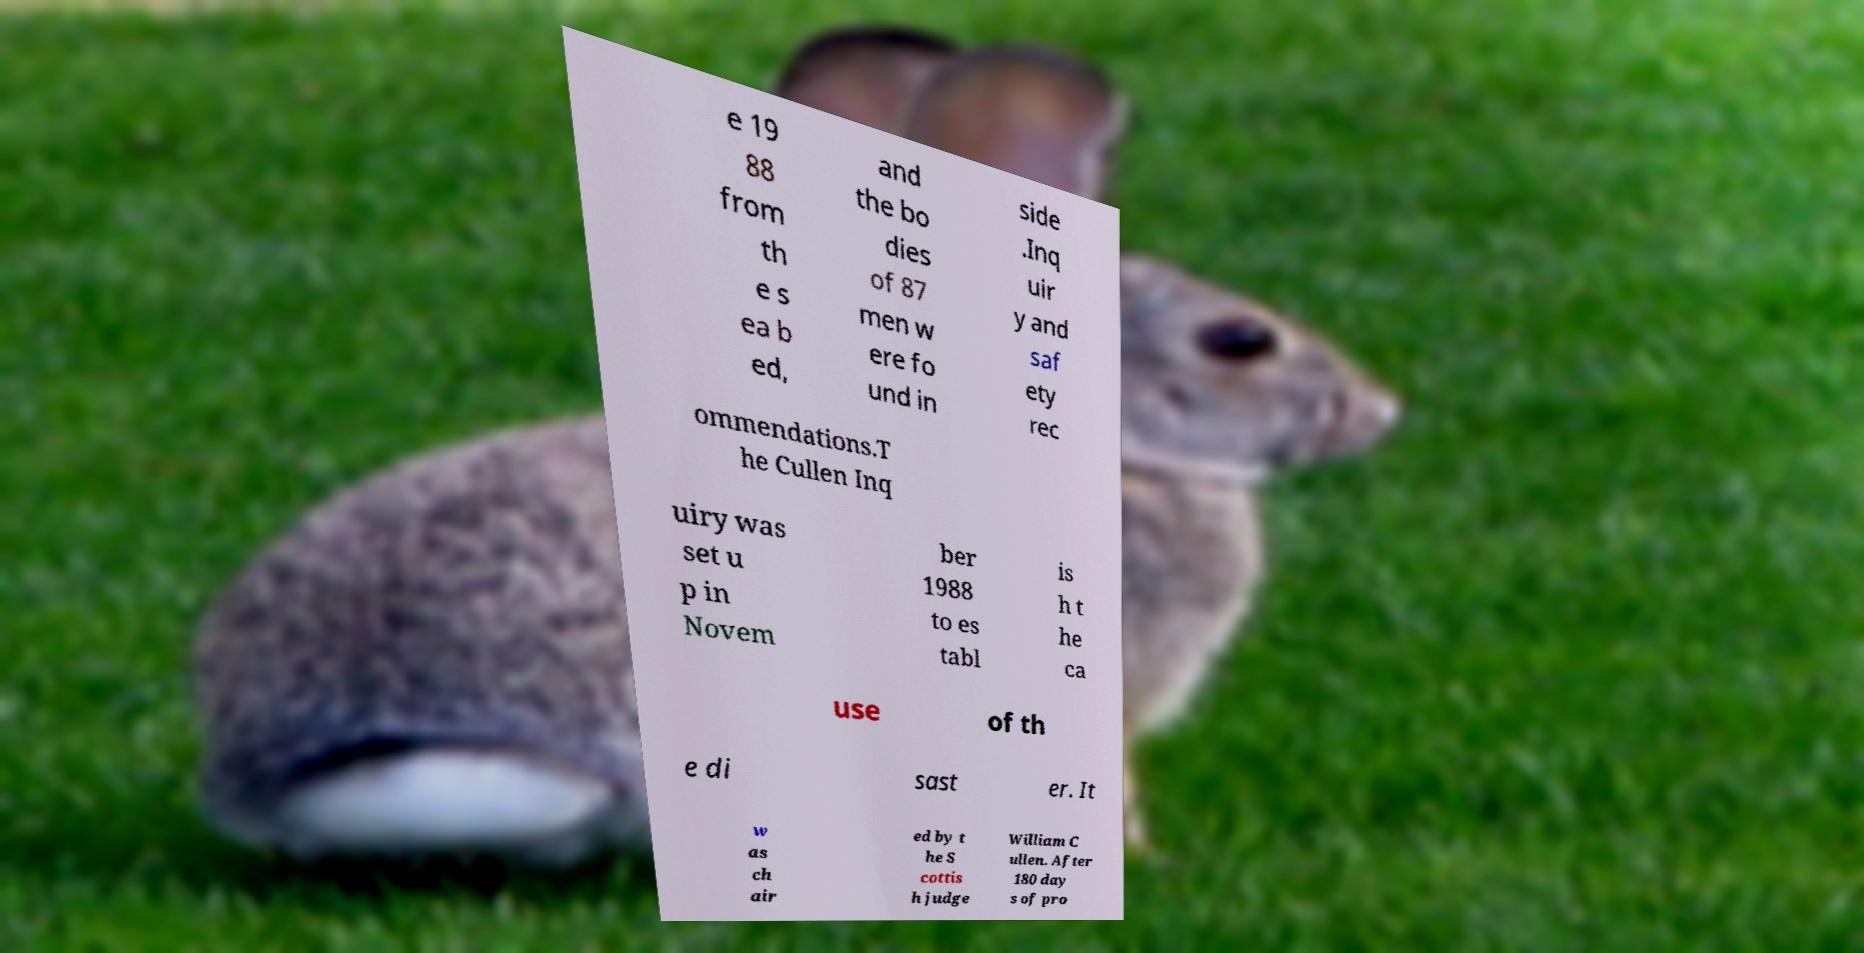Could you assist in decoding the text presented in this image and type it out clearly? e 19 88 from th e s ea b ed, and the bo dies of 87 men w ere fo und in side .Inq uir y and saf ety rec ommendations.T he Cullen Inq uiry was set u p in Novem ber 1988 to es tabl is h t he ca use of th e di sast er. It w as ch air ed by t he S cottis h judge William C ullen. After 180 day s of pro 